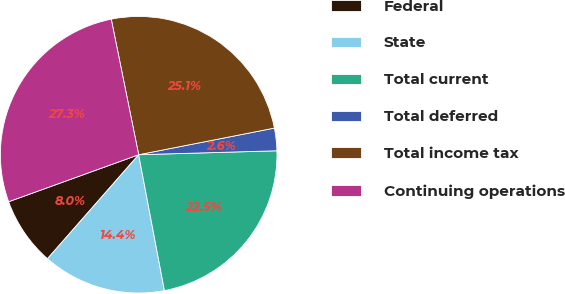Convert chart to OTSL. <chart><loc_0><loc_0><loc_500><loc_500><pie_chart><fcel>Federal<fcel>State<fcel>Total current<fcel>Total deferred<fcel>Total income tax<fcel>Continuing operations<nl><fcel>8.02%<fcel>14.44%<fcel>22.47%<fcel>2.63%<fcel>25.09%<fcel>27.34%<nl></chart> 